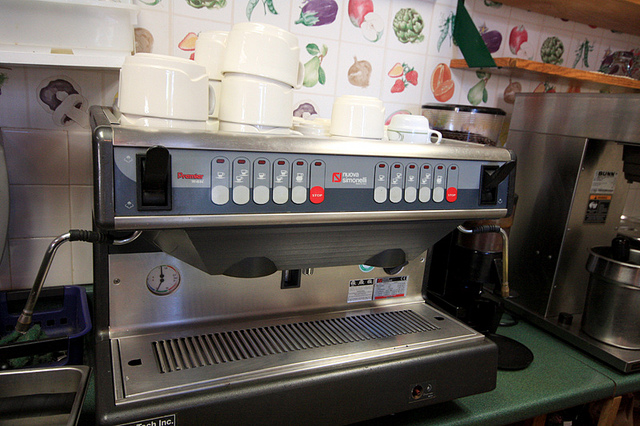How many people in the boats? It appears there has been a misunderstanding as the image does not depict any boats or people. What is shown in the image is a professional espresso machine, commonly used in cafés, with multiple group heads for making coffee. It also has several coffee cups on top for warming. 